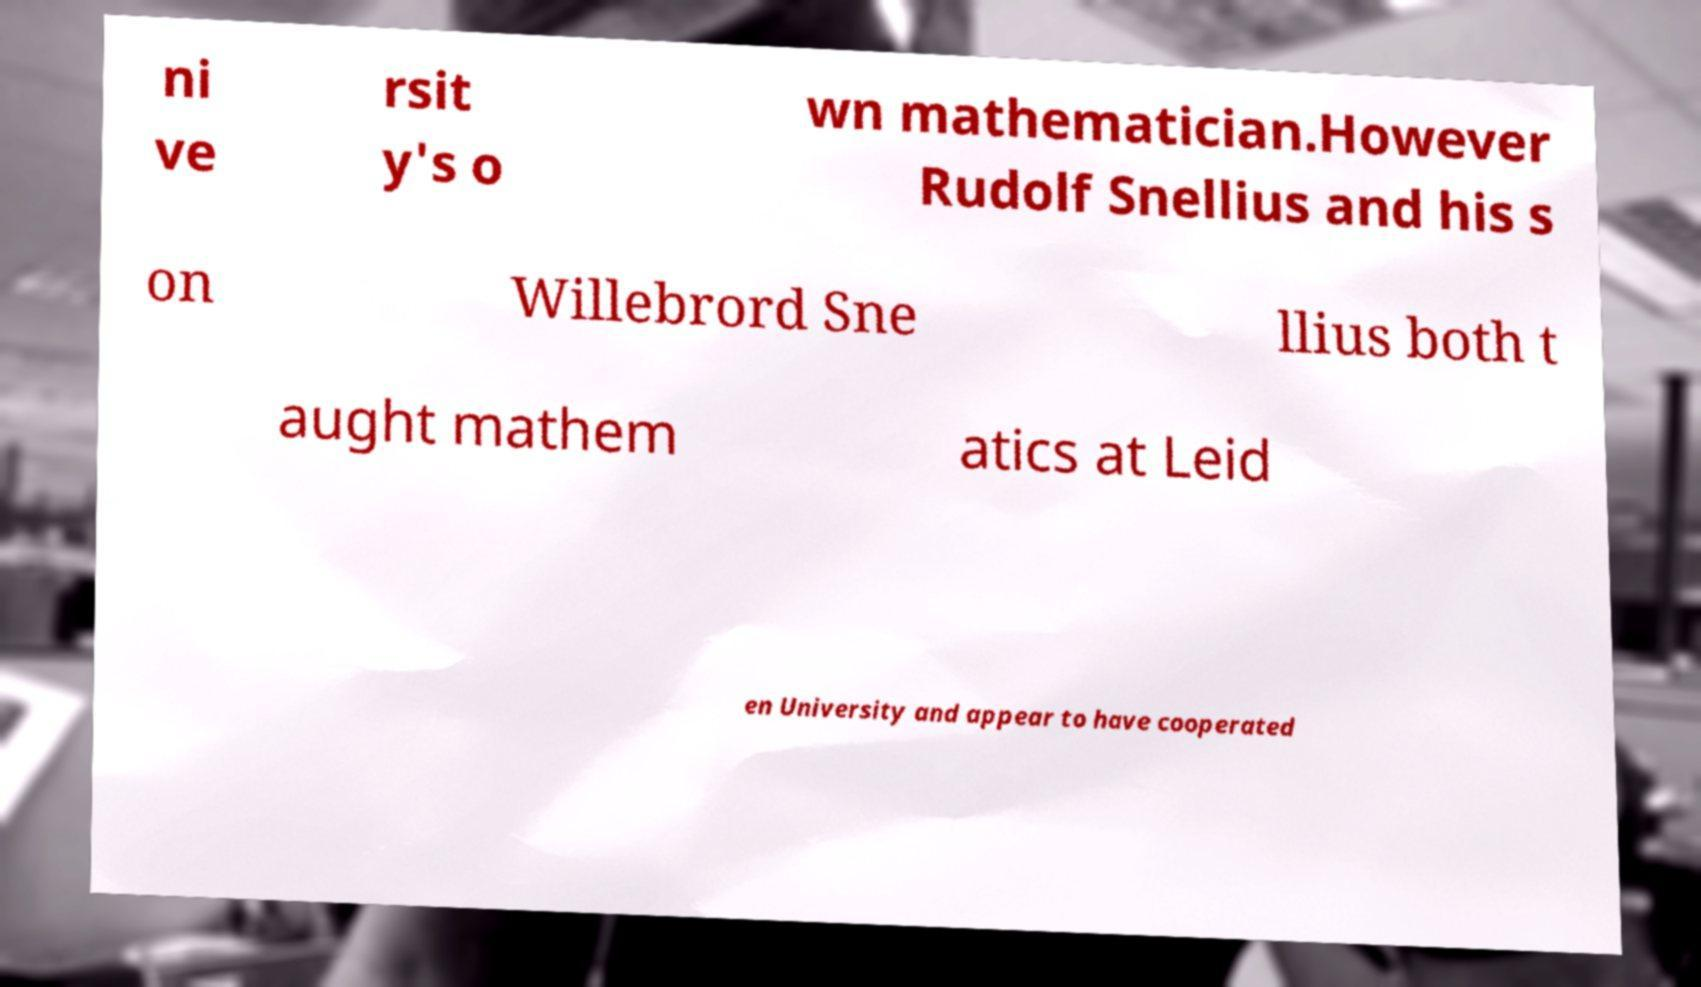What messages or text are displayed in this image? I need them in a readable, typed format. ni ve rsit y's o wn mathematician.However Rudolf Snellius and his s on Willebrord Sne llius both t aught mathem atics at Leid en University and appear to have cooperated 